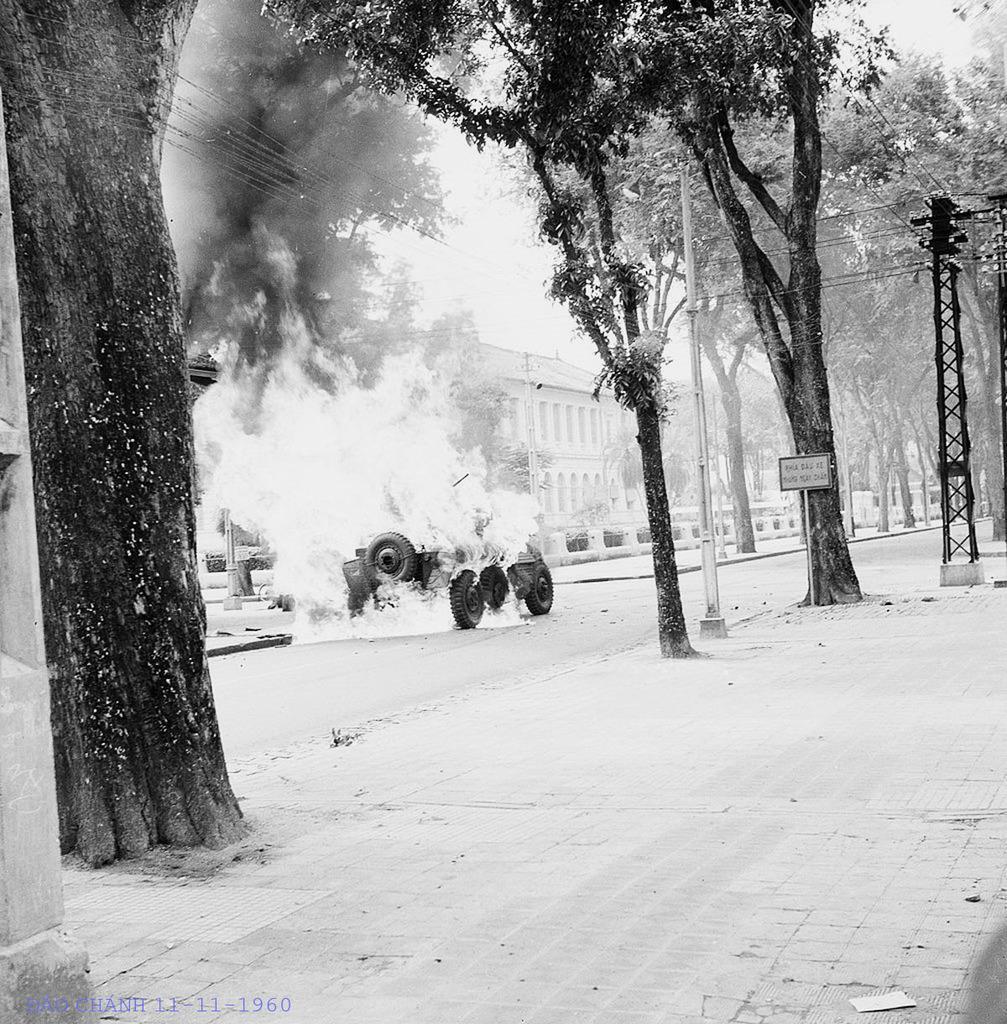Describe this image in one or two sentences. In this image I can see trees, board, light poles, wires and a vehicle burnt in fire. In the background I can see buildings. On the top I can see the sky. This image is taken during a day. 